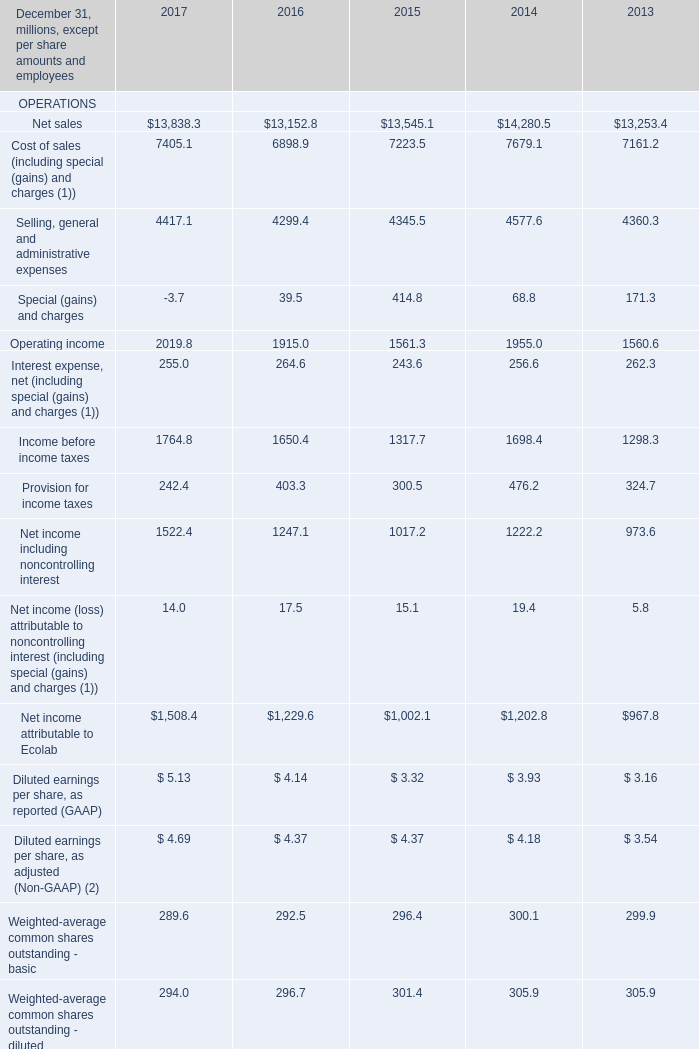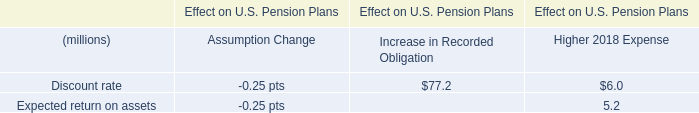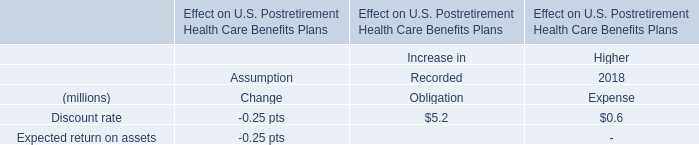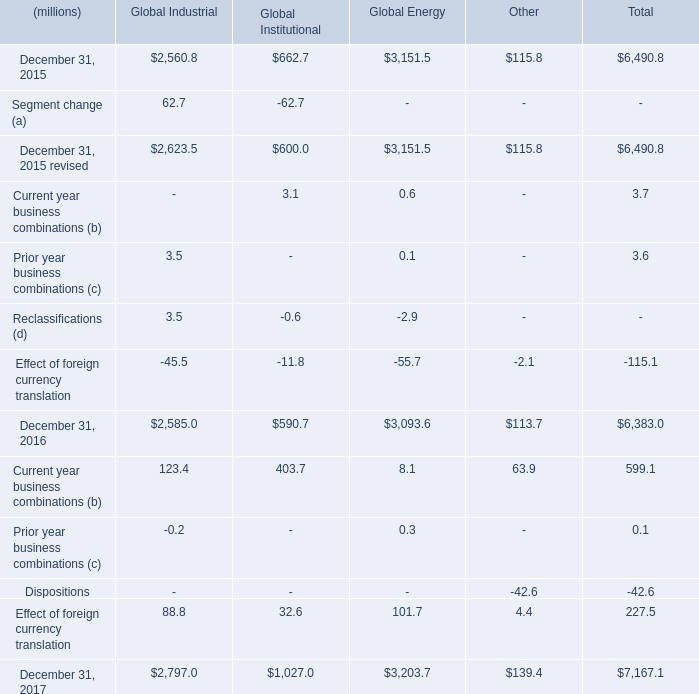what's the total amount of December 31, 2017 of Global Industrial, and Current assets FINANCIAL POSITION of 2015 ? 
Computations: (2797.0 + 4447.5)
Answer: 7244.5. 